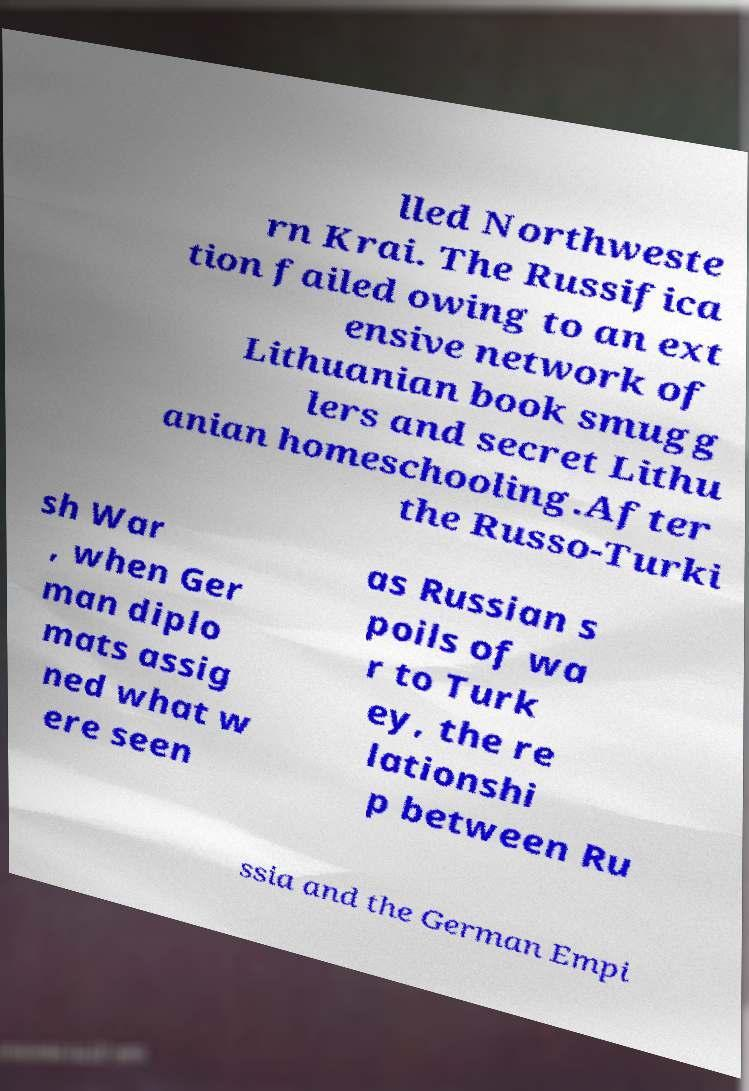What messages or text are displayed in this image? I need them in a readable, typed format. lled Northweste rn Krai. The Russifica tion failed owing to an ext ensive network of Lithuanian book smugg lers and secret Lithu anian homeschooling.After the Russo-Turki sh War , when Ger man diplo mats assig ned what w ere seen as Russian s poils of wa r to Turk ey, the re lationshi p between Ru ssia and the German Empi 